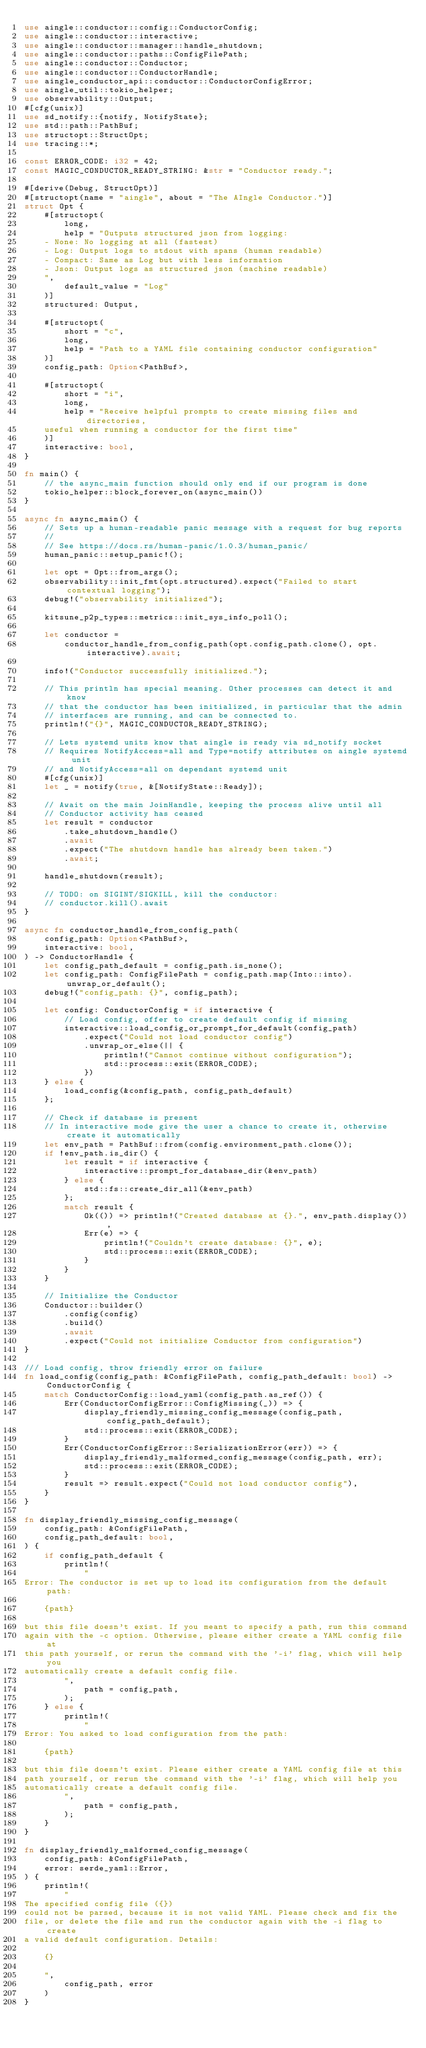<code> <loc_0><loc_0><loc_500><loc_500><_Rust_>use aingle::conductor::config::ConductorConfig;
use aingle::conductor::interactive;
use aingle::conductor::manager::handle_shutdown;
use aingle::conductor::paths::ConfigFilePath;
use aingle::conductor::Conductor;
use aingle::conductor::ConductorHandle;
use aingle_conductor_api::conductor::ConductorConfigError;
use aingle_util::tokio_helper;
use observability::Output;
#[cfg(unix)]
use sd_notify::{notify, NotifyState};
use std::path::PathBuf;
use structopt::StructOpt;
use tracing::*;

const ERROR_CODE: i32 = 42;
const MAGIC_CONDUCTOR_READY_STRING: &str = "Conductor ready.";

#[derive(Debug, StructOpt)]
#[structopt(name = "aingle", about = "The AIngle Conductor.")]
struct Opt {
    #[structopt(
        long,
        help = "Outputs structured json from logging:
    - None: No logging at all (fastest)
    - Log: Output logs to stdout with spans (human readable)
    - Compact: Same as Log but with less information
    - Json: Output logs as structured json (machine readable)
    ",
        default_value = "Log"
    )]
    structured: Output,

    #[structopt(
        short = "c",
        long,
        help = "Path to a YAML file containing conductor configuration"
    )]
    config_path: Option<PathBuf>,

    #[structopt(
        short = "i",
        long,
        help = "Receive helpful prompts to create missing files and directories,
    useful when running a conductor for the first time"
    )]
    interactive: bool,
}

fn main() {
    // the async_main function should only end if our program is done
    tokio_helper::block_forever_on(async_main())
}

async fn async_main() {
    // Sets up a human-readable panic message with a request for bug reports
    //
    // See https://docs.rs/human-panic/1.0.3/human_panic/
    human_panic::setup_panic!();

    let opt = Opt::from_args();
    observability::init_fmt(opt.structured).expect("Failed to start contextual logging");
    debug!("observability initialized");

    kitsune_p2p_types::metrics::init_sys_info_poll();

    let conductor =
        conductor_handle_from_config_path(opt.config_path.clone(), opt.interactive).await;

    info!("Conductor successfully initialized.");

    // This println has special meaning. Other processes can detect it and know
    // that the conductor has been initialized, in particular that the admin
    // interfaces are running, and can be connected to.
    println!("{}", MAGIC_CONDUCTOR_READY_STRING);

    // Lets systemd units know that aingle is ready via sd_notify socket
    // Requires NotifyAccess=all and Type=notify attributes on aingle systemd unit
    // and NotifyAccess=all on dependant systemd unit
    #[cfg(unix)]
    let _ = notify(true, &[NotifyState::Ready]);

    // Await on the main JoinHandle, keeping the process alive until all
    // Conductor activity has ceased
    let result = conductor
        .take_shutdown_handle()
        .await
        .expect("The shutdown handle has already been taken.")
        .await;

    handle_shutdown(result);

    // TODO: on SIGINT/SIGKILL, kill the conductor:
    // conductor.kill().await
}

async fn conductor_handle_from_config_path(
    config_path: Option<PathBuf>,
    interactive: bool,
) -> ConductorHandle {
    let config_path_default = config_path.is_none();
    let config_path: ConfigFilePath = config_path.map(Into::into).unwrap_or_default();
    debug!("config_path: {}", config_path);

    let config: ConductorConfig = if interactive {
        // Load config, offer to create default config if missing
        interactive::load_config_or_prompt_for_default(config_path)
            .expect("Could not load conductor config")
            .unwrap_or_else(|| {
                println!("Cannot continue without configuration");
                std::process::exit(ERROR_CODE);
            })
    } else {
        load_config(&config_path, config_path_default)
    };

    // Check if database is present
    // In interactive mode give the user a chance to create it, otherwise create it automatically
    let env_path = PathBuf::from(config.environment_path.clone());
    if !env_path.is_dir() {
        let result = if interactive {
            interactive::prompt_for_database_dir(&env_path)
        } else {
            std::fs::create_dir_all(&env_path)
        };
        match result {
            Ok(()) => println!("Created database at {}.", env_path.display()),
            Err(e) => {
                println!("Couldn't create database: {}", e);
                std::process::exit(ERROR_CODE);
            }
        }
    }

    // Initialize the Conductor
    Conductor::builder()
        .config(config)
        .build()
        .await
        .expect("Could not initialize Conductor from configuration")
}

/// Load config, throw friendly error on failure
fn load_config(config_path: &ConfigFilePath, config_path_default: bool) -> ConductorConfig {
    match ConductorConfig::load_yaml(config_path.as_ref()) {
        Err(ConductorConfigError::ConfigMissing(_)) => {
            display_friendly_missing_config_message(config_path, config_path_default);
            std::process::exit(ERROR_CODE);
        }
        Err(ConductorConfigError::SerializationError(err)) => {
            display_friendly_malformed_config_message(config_path, err);
            std::process::exit(ERROR_CODE);
        }
        result => result.expect("Could not load conductor config"),
    }
}

fn display_friendly_missing_config_message(
    config_path: &ConfigFilePath,
    config_path_default: bool,
) {
    if config_path_default {
        println!(
            "
Error: The conductor is set up to load its configuration from the default path:

    {path}

but this file doesn't exist. If you meant to specify a path, run this command
again with the -c option. Otherwise, please either create a YAML config file at
this path yourself, or rerun the command with the '-i' flag, which will help you
automatically create a default config file.
        ",
            path = config_path,
        );
    } else {
        println!(
            "
Error: You asked to load configuration from the path:

    {path}

but this file doesn't exist. Please either create a YAML config file at this
path yourself, or rerun the command with the '-i' flag, which will help you
automatically create a default config file.
        ",
            path = config_path,
        );
    }
}

fn display_friendly_malformed_config_message(
    config_path: &ConfigFilePath,
    error: serde_yaml::Error,
) {
    println!(
        "
The specified config file ({})
could not be parsed, because it is not valid YAML. Please check and fix the
file, or delete the file and run the conductor again with the -i flag to create
a valid default configuration. Details:

    {}

    ",
        config_path, error
    )
}
</code> 